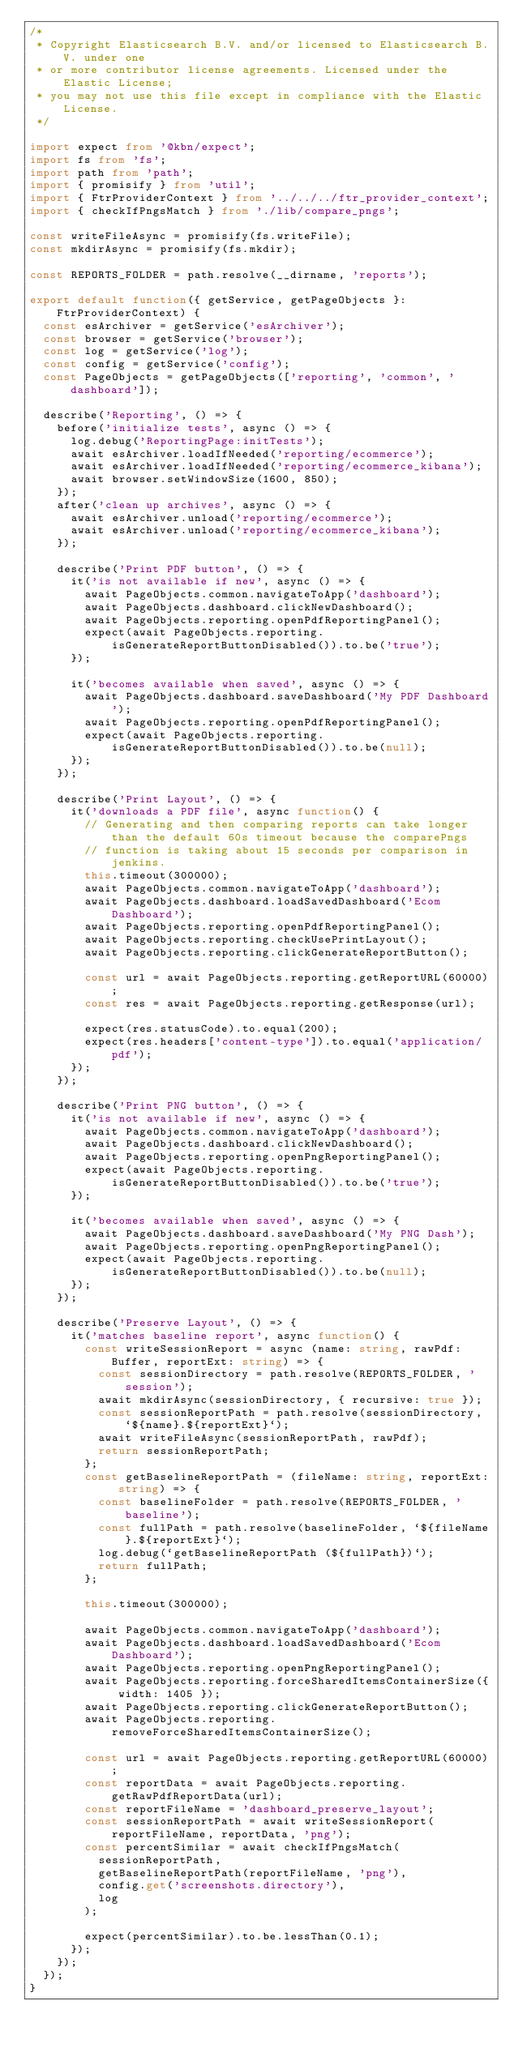<code> <loc_0><loc_0><loc_500><loc_500><_TypeScript_>/*
 * Copyright Elasticsearch B.V. and/or licensed to Elasticsearch B.V. under one
 * or more contributor license agreements. Licensed under the Elastic License;
 * you may not use this file except in compliance with the Elastic License.
 */

import expect from '@kbn/expect';
import fs from 'fs';
import path from 'path';
import { promisify } from 'util';
import { FtrProviderContext } from '../../../ftr_provider_context';
import { checkIfPngsMatch } from './lib/compare_pngs';

const writeFileAsync = promisify(fs.writeFile);
const mkdirAsync = promisify(fs.mkdir);

const REPORTS_FOLDER = path.resolve(__dirname, 'reports');

export default function({ getService, getPageObjects }: FtrProviderContext) {
  const esArchiver = getService('esArchiver');
  const browser = getService('browser');
  const log = getService('log');
  const config = getService('config');
  const PageObjects = getPageObjects(['reporting', 'common', 'dashboard']);

  describe('Reporting', () => {
    before('initialize tests', async () => {
      log.debug('ReportingPage:initTests');
      await esArchiver.loadIfNeeded('reporting/ecommerce');
      await esArchiver.loadIfNeeded('reporting/ecommerce_kibana');
      await browser.setWindowSize(1600, 850);
    });
    after('clean up archives', async () => {
      await esArchiver.unload('reporting/ecommerce');
      await esArchiver.unload('reporting/ecommerce_kibana');
    });

    describe('Print PDF button', () => {
      it('is not available if new', async () => {
        await PageObjects.common.navigateToApp('dashboard');
        await PageObjects.dashboard.clickNewDashboard();
        await PageObjects.reporting.openPdfReportingPanel();
        expect(await PageObjects.reporting.isGenerateReportButtonDisabled()).to.be('true');
      });

      it('becomes available when saved', async () => {
        await PageObjects.dashboard.saveDashboard('My PDF Dashboard');
        await PageObjects.reporting.openPdfReportingPanel();
        expect(await PageObjects.reporting.isGenerateReportButtonDisabled()).to.be(null);
      });
    });

    describe('Print Layout', () => {
      it('downloads a PDF file', async function() {
        // Generating and then comparing reports can take longer than the default 60s timeout because the comparePngs
        // function is taking about 15 seconds per comparison in jenkins.
        this.timeout(300000);
        await PageObjects.common.navigateToApp('dashboard');
        await PageObjects.dashboard.loadSavedDashboard('Ecom Dashboard');
        await PageObjects.reporting.openPdfReportingPanel();
        await PageObjects.reporting.checkUsePrintLayout();
        await PageObjects.reporting.clickGenerateReportButton();

        const url = await PageObjects.reporting.getReportURL(60000);
        const res = await PageObjects.reporting.getResponse(url);

        expect(res.statusCode).to.equal(200);
        expect(res.headers['content-type']).to.equal('application/pdf');
      });
    });

    describe('Print PNG button', () => {
      it('is not available if new', async () => {
        await PageObjects.common.navigateToApp('dashboard');
        await PageObjects.dashboard.clickNewDashboard();
        await PageObjects.reporting.openPngReportingPanel();
        expect(await PageObjects.reporting.isGenerateReportButtonDisabled()).to.be('true');
      });

      it('becomes available when saved', async () => {
        await PageObjects.dashboard.saveDashboard('My PNG Dash');
        await PageObjects.reporting.openPngReportingPanel();
        expect(await PageObjects.reporting.isGenerateReportButtonDisabled()).to.be(null);
      });
    });

    describe('Preserve Layout', () => {
      it('matches baseline report', async function() {
        const writeSessionReport = async (name: string, rawPdf: Buffer, reportExt: string) => {
          const sessionDirectory = path.resolve(REPORTS_FOLDER, 'session');
          await mkdirAsync(sessionDirectory, { recursive: true });
          const sessionReportPath = path.resolve(sessionDirectory, `${name}.${reportExt}`);
          await writeFileAsync(sessionReportPath, rawPdf);
          return sessionReportPath;
        };
        const getBaselineReportPath = (fileName: string, reportExt: string) => {
          const baselineFolder = path.resolve(REPORTS_FOLDER, 'baseline');
          const fullPath = path.resolve(baselineFolder, `${fileName}.${reportExt}`);
          log.debug(`getBaselineReportPath (${fullPath})`);
          return fullPath;
        };

        this.timeout(300000);

        await PageObjects.common.navigateToApp('dashboard');
        await PageObjects.dashboard.loadSavedDashboard('Ecom Dashboard');
        await PageObjects.reporting.openPngReportingPanel();
        await PageObjects.reporting.forceSharedItemsContainerSize({ width: 1405 });
        await PageObjects.reporting.clickGenerateReportButton();
        await PageObjects.reporting.removeForceSharedItemsContainerSize();

        const url = await PageObjects.reporting.getReportURL(60000);
        const reportData = await PageObjects.reporting.getRawPdfReportData(url);
        const reportFileName = 'dashboard_preserve_layout';
        const sessionReportPath = await writeSessionReport(reportFileName, reportData, 'png');
        const percentSimilar = await checkIfPngsMatch(
          sessionReportPath,
          getBaselineReportPath(reportFileName, 'png'),
          config.get('screenshots.directory'),
          log
        );

        expect(percentSimilar).to.be.lessThan(0.1);
      });
    });
  });
}
</code> 